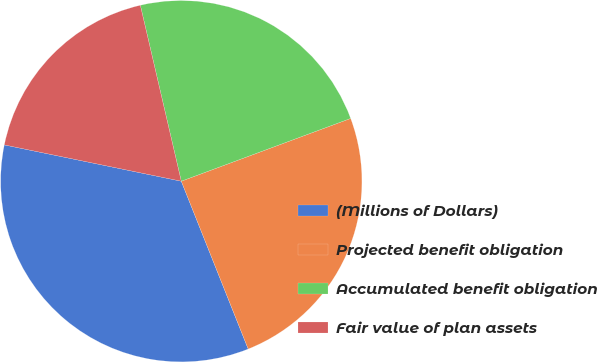Convert chart. <chart><loc_0><loc_0><loc_500><loc_500><pie_chart><fcel>(Millions of Dollars)<fcel>Projected benefit obligation<fcel>Accumulated benefit obligation<fcel>Fair value of plan assets<nl><fcel>34.26%<fcel>24.61%<fcel>22.99%<fcel>18.14%<nl></chart> 